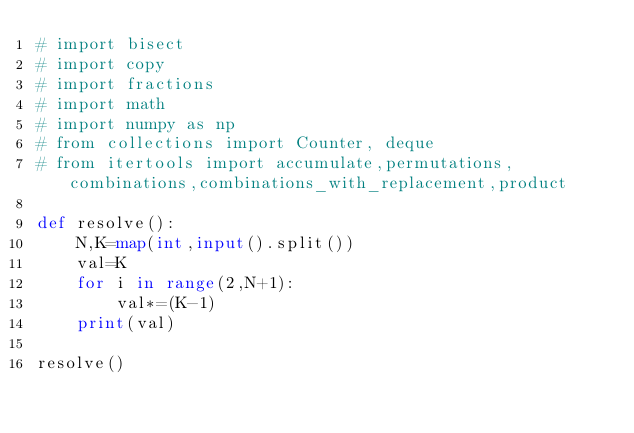Convert code to text. <code><loc_0><loc_0><loc_500><loc_500><_Python_># import bisect
# import copy
# import fractions
# import math
# import numpy as np
# from collections import Counter, deque
# from itertools import accumulate,permutations, combinations,combinations_with_replacement,product

def resolve():
    N,K=map(int,input().split())
    val=K
    for i in range(2,N+1):
        val*=(K-1)
    print(val)

resolve()</code> 